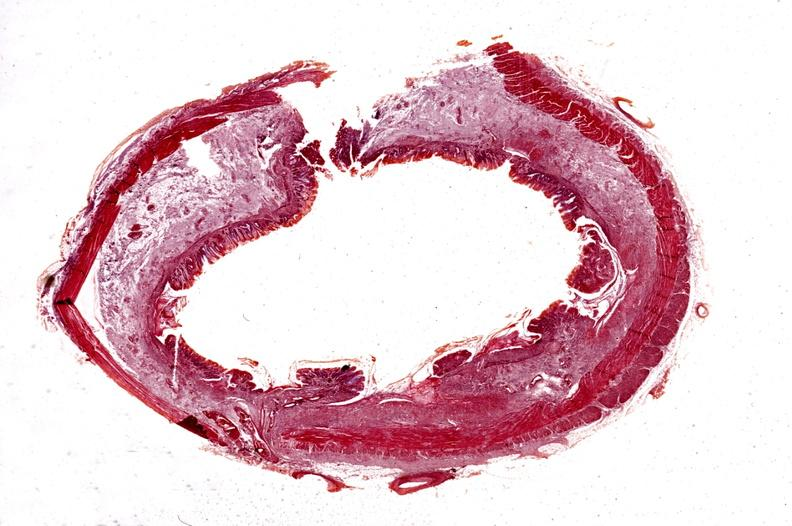s gastrointestinal present?
Answer the question using a single word or phrase. Yes 